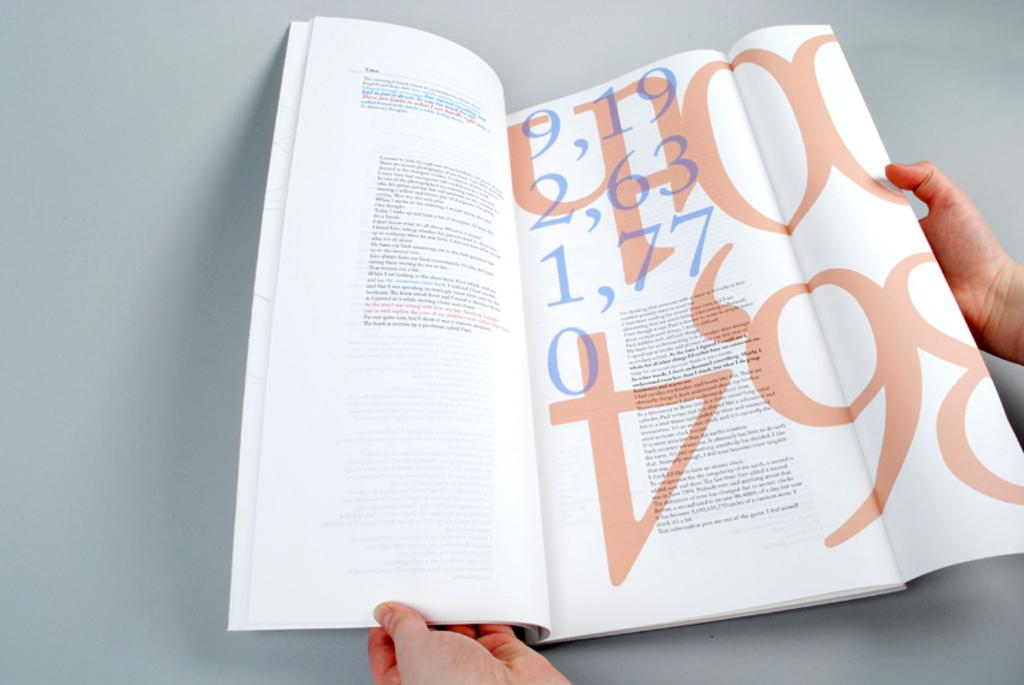<image>
Create a compact narrative representing the image presented. A person holds a document with the number 6 and 4 written in red upside down. 